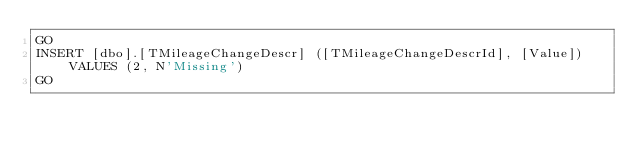<code> <loc_0><loc_0><loc_500><loc_500><_SQL_>GO
INSERT [dbo].[TMileageChangeDescr] ([TMileageChangeDescrId], [Value]) VALUES (2, N'Missing')
GO
</code> 